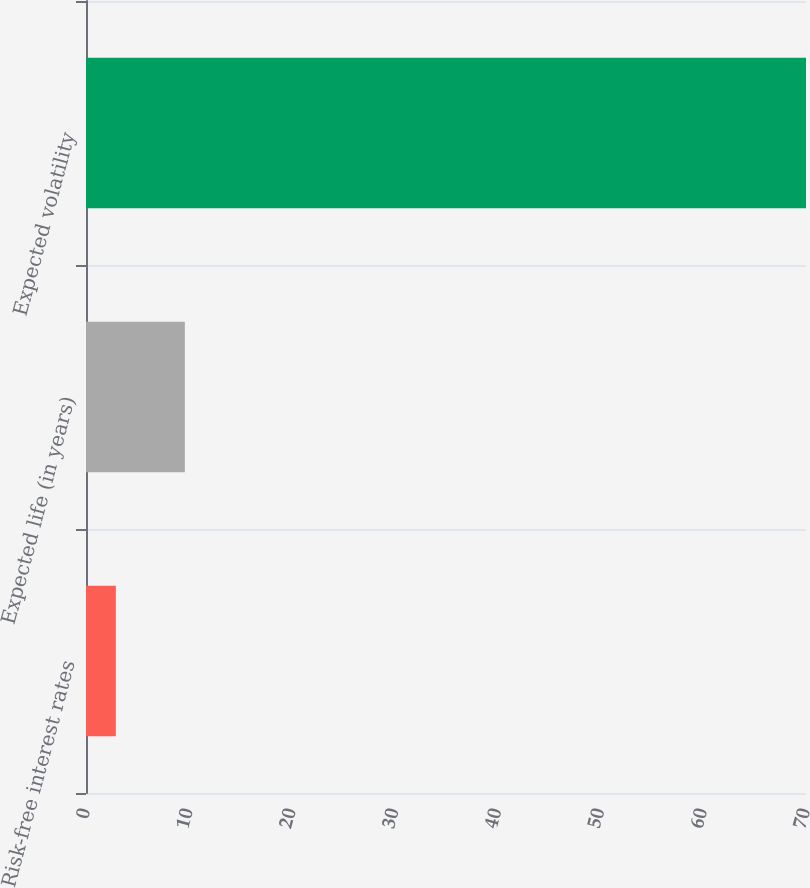Convert chart. <chart><loc_0><loc_0><loc_500><loc_500><bar_chart><fcel>Risk-free interest rates<fcel>Expected life (in years)<fcel>Expected volatility<nl><fcel>2.9<fcel>9.61<fcel>70<nl></chart> 